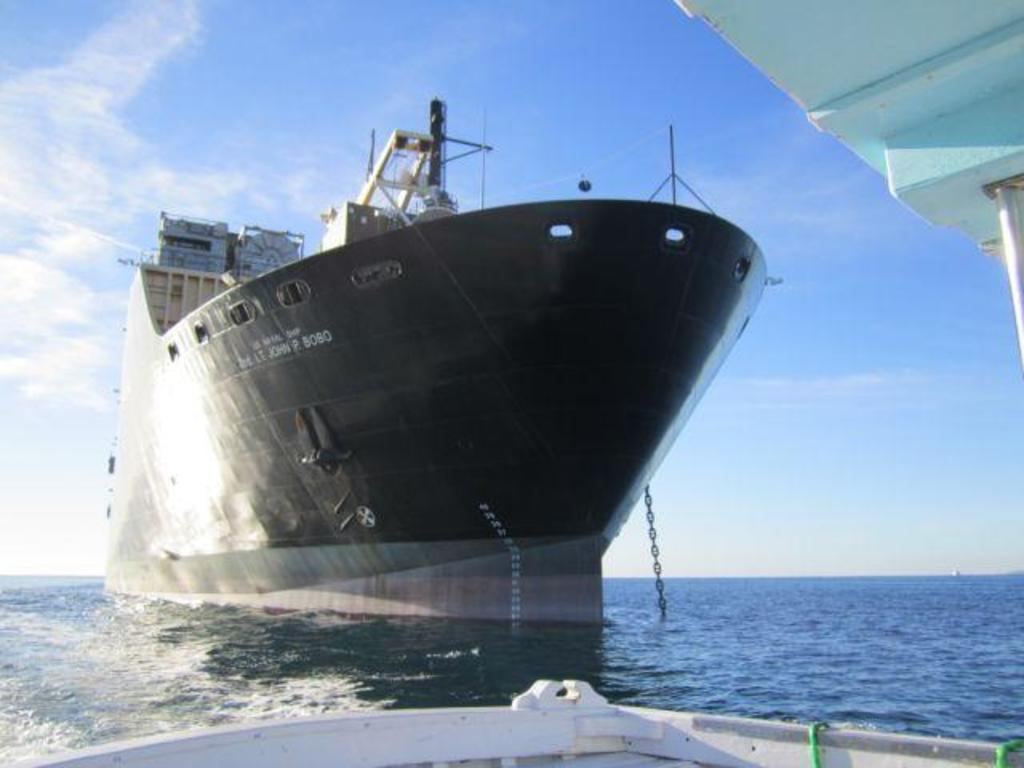What is the main subject in the middle of the image? There is a boat in the middle of the image. What type of environment is depicted in the image? The image shows water at the bottom and the sky at the top, suggesting a water-based setting. What type of silk is being used to create the apparatus in the image? There is no silk or apparatus present in the image; it features a boat in a water-based setting. 